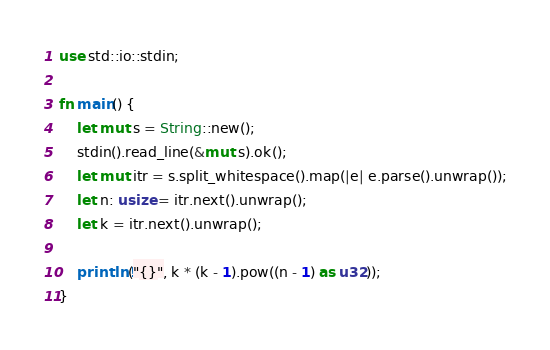Convert code to text. <code><loc_0><loc_0><loc_500><loc_500><_Rust_>use std::io::stdin;

fn main() {
    let mut s = String::new();
    stdin().read_line(&mut s).ok();
    let mut itr = s.split_whitespace().map(|e| e.parse().unwrap());
    let n: usize = itr.next().unwrap();
    let k = itr.next().unwrap();

    println!("{}", k * (k - 1).pow((n - 1) as u32));
}
</code> 